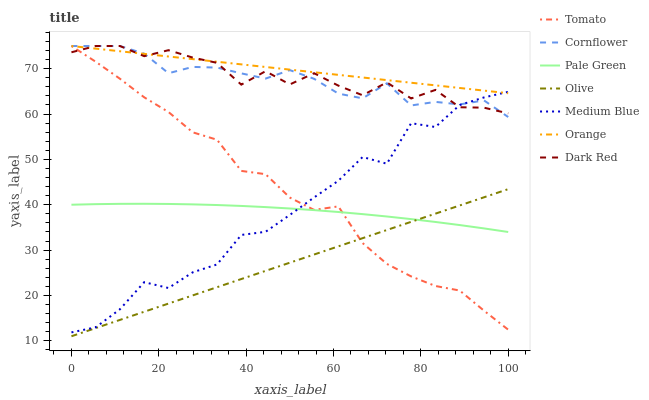Does Olive have the minimum area under the curve?
Answer yes or no. Yes. Does Orange have the maximum area under the curve?
Answer yes or no. Yes. Does Cornflower have the minimum area under the curve?
Answer yes or no. No. Does Cornflower have the maximum area under the curve?
Answer yes or no. No. Is Olive the smoothest?
Answer yes or no. Yes. Is Medium Blue the roughest?
Answer yes or no. Yes. Is Cornflower the smoothest?
Answer yes or no. No. Is Cornflower the roughest?
Answer yes or no. No. Does Olive have the lowest value?
Answer yes or no. Yes. Does Cornflower have the lowest value?
Answer yes or no. No. Does Orange have the highest value?
Answer yes or no. Yes. Does Medium Blue have the highest value?
Answer yes or no. No. Is Olive less than Dark Red?
Answer yes or no. Yes. Is Orange greater than Pale Green?
Answer yes or no. Yes. Does Olive intersect Tomato?
Answer yes or no. Yes. Is Olive less than Tomato?
Answer yes or no. No. Is Olive greater than Tomato?
Answer yes or no. No. Does Olive intersect Dark Red?
Answer yes or no. No. 